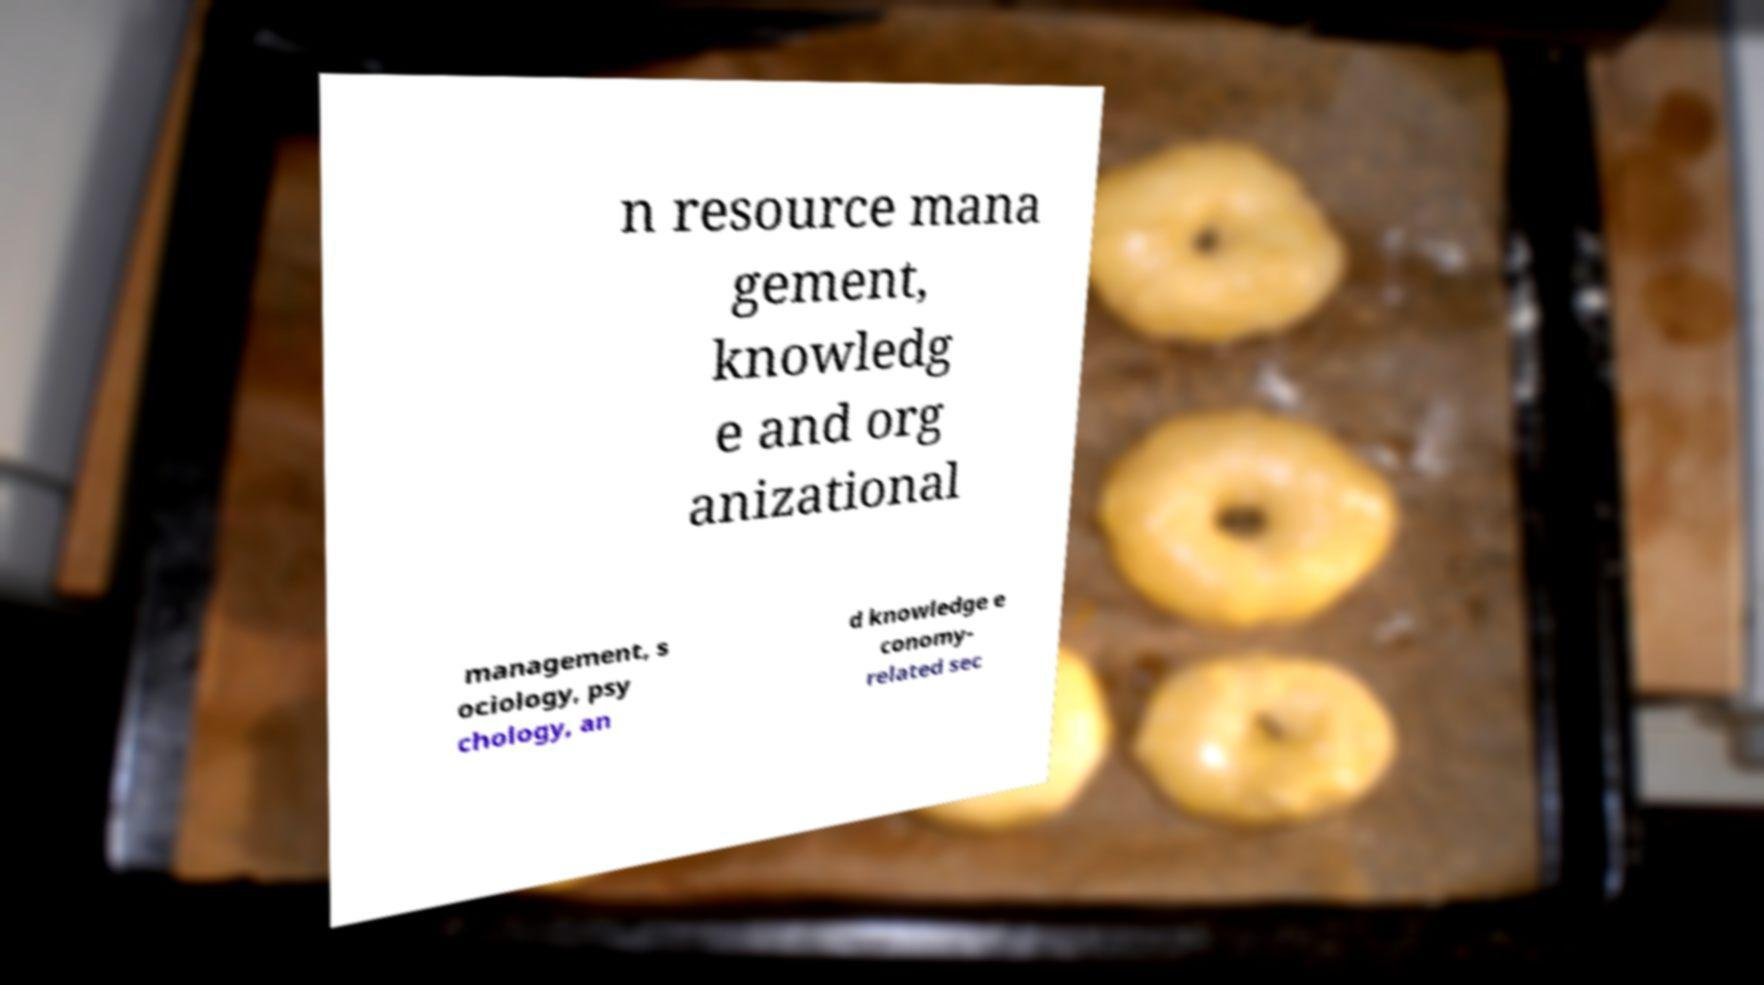For documentation purposes, I need the text within this image transcribed. Could you provide that? n resource mana gement, knowledg e and org anizational management, s ociology, psy chology, an d knowledge e conomy- related sec 